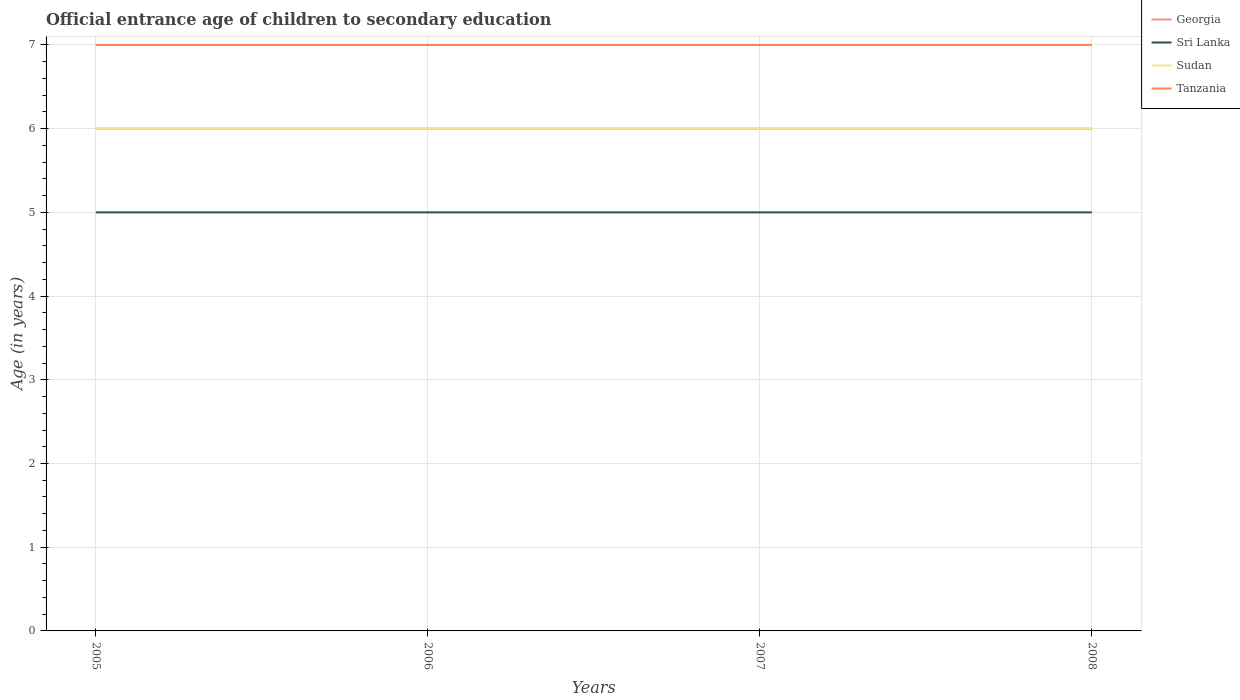In which year was the secondary school starting age of children in Georgia maximum?
Your response must be concise. 2005. What is the total secondary school starting age of children in Tanzania in the graph?
Keep it short and to the point. 0. What is the difference between the highest and the second highest secondary school starting age of children in Tanzania?
Make the answer very short. 0. What is the difference between the highest and the lowest secondary school starting age of children in Tanzania?
Offer a terse response. 0. Is the secondary school starting age of children in Sri Lanka strictly greater than the secondary school starting age of children in Sudan over the years?
Offer a terse response. Yes. How many years are there in the graph?
Offer a terse response. 4. How many legend labels are there?
Provide a succinct answer. 4. What is the title of the graph?
Make the answer very short. Official entrance age of children to secondary education. What is the label or title of the X-axis?
Offer a terse response. Years. What is the label or title of the Y-axis?
Make the answer very short. Age (in years). What is the Age (in years) of Sudan in 2005?
Your response must be concise. 6. What is the Age (in years) in Sri Lanka in 2006?
Your answer should be compact. 5. What is the Age (in years) of Sudan in 2006?
Offer a terse response. 6. What is the Age (in years) of Sri Lanka in 2007?
Make the answer very short. 5. What is the Age (in years) in Georgia in 2008?
Ensure brevity in your answer.  6. What is the Age (in years) in Sri Lanka in 2008?
Make the answer very short. 5. What is the Age (in years) of Sudan in 2008?
Your answer should be very brief. 6. What is the Age (in years) of Tanzania in 2008?
Ensure brevity in your answer.  7. Across all years, what is the maximum Age (in years) of Georgia?
Provide a succinct answer. 6. Across all years, what is the maximum Age (in years) in Sri Lanka?
Your response must be concise. 5. Across all years, what is the maximum Age (in years) of Sudan?
Your response must be concise. 6. Across all years, what is the minimum Age (in years) of Georgia?
Offer a terse response. 6. Across all years, what is the minimum Age (in years) in Sri Lanka?
Ensure brevity in your answer.  5. Across all years, what is the minimum Age (in years) of Sudan?
Your response must be concise. 6. What is the total Age (in years) of Sri Lanka in the graph?
Ensure brevity in your answer.  20. What is the difference between the Age (in years) in Georgia in 2005 and that in 2006?
Your answer should be very brief. 0. What is the difference between the Age (in years) in Georgia in 2005 and that in 2007?
Make the answer very short. 0. What is the difference between the Age (in years) of Sri Lanka in 2005 and that in 2007?
Your answer should be very brief. 0. What is the difference between the Age (in years) of Sudan in 2005 and that in 2007?
Your response must be concise. 0. What is the difference between the Age (in years) of Tanzania in 2005 and that in 2007?
Provide a short and direct response. 0. What is the difference between the Age (in years) of Georgia in 2005 and that in 2008?
Provide a succinct answer. 0. What is the difference between the Age (in years) in Sudan in 2005 and that in 2008?
Offer a terse response. 0. What is the difference between the Age (in years) in Tanzania in 2005 and that in 2008?
Your answer should be very brief. 0. What is the difference between the Age (in years) in Sri Lanka in 2006 and that in 2007?
Keep it short and to the point. 0. What is the difference between the Age (in years) in Tanzania in 2006 and that in 2007?
Your answer should be very brief. 0. What is the difference between the Age (in years) in Georgia in 2006 and that in 2008?
Your answer should be very brief. 0. What is the difference between the Age (in years) of Sri Lanka in 2006 and that in 2008?
Give a very brief answer. 0. What is the difference between the Age (in years) in Tanzania in 2006 and that in 2008?
Offer a terse response. 0. What is the difference between the Age (in years) of Tanzania in 2007 and that in 2008?
Your answer should be compact. 0. What is the difference between the Age (in years) of Georgia in 2005 and the Age (in years) of Sudan in 2006?
Your response must be concise. 0. What is the difference between the Age (in years) of Georgia in 2005 and the Age (in years) of Tanzania in 2006?
Offer a terse response. -1. What is the difference between the Age (in years) in Georgia in 2005 and the Age (in years) in Sri Lanka in 2007?
Provide a succinct answer. 1. What is the difference between the Age (in years) of Georgia in 2005 and the Age (in years) of Sudan in 2007?
Keep it short and to the point. 0. What is the difference between the Age (in years) of Georgia in 2005 and the Age (in years) of Tanzania in 2007?
Provide a succinct answer. -1. What is the difference between the Age (in years) of Sri Lanka in 2005 and the Age (in years) of Sudan in 2007?
Provide a succinct answer. -1. What is the difference between the Age (in years) in Sudan in 2005 and the Age (in years) in Tanzania in 2007?
Give a very brief answer. -1. What is the difference between the Age (in years) in Georgia in 2005 and the Age (in years) in Tanzania in 2008?
Offer a very short reply. -1. What is the difference between the Age (in years) of Sudan in 2005 and the Age (in years) of Tanzania in 2008?
Offer a terse response. -1. What is the difference between the Age (in years) of Georgia in 2006 and the Age (in years) of Sri Lanka in 2007?
Your answer should be compact. 1. What is the difference between the Age (in years) of Georgia in 2006 and the Age (in years) of Sudan in 2007?
Your answer should be very brief. 0. What is the difference between the Age (in years) in Sri Lanka in 2006 and the Age (in years) in Tanzania in 2007?
Ensure brevity in your answer.  -2. What is the difference between the Age (in years) in Georgia in 2006 and the Age (in years) in Sri Lanka in 2008?
Provide a short and direct response. 1. What is the difference between the Age (in years) in Georgia in 2006 and the Age (in years) in Tanzania in 2008?
Keep it short and to the point. -1. What is the difference between the Age (in years) in Georgia in 2007 and the Age (in years) in Tanzania in 2008?
Provide a short and direct response. -1. What is the difference between the Age (in years) of Sri Lanka in 2007 and the Age (in years) of Tanzania in 2008?
Offer a very short reply. -2. What is the difference between the Age (in years) in Sudan in 2007 and the Age (in years) in Tanzania in 2008?
Provide a short and direct response. -1. What is the average Age (in years) of Georgia per year?
Keep it short and to the point. 6. What is the average Age (in years) in Sri Lanka per year?
Your answer should be very brief. 5. What is the average Age (in years) in Tanzania per year?
Your answer should be very brief. 7. In the year 2005, what is the difference between the Age (in years) in Georgia and Age (in years) in Sri Lanka?
Your answer should be very brief. 1. In the year 2005, what is the difference between the Age (in years) in Georgia and Age (in years) in Sudan?
Your answer should be very brief. 0. In the year 2005, what is the difference between the Age (in years) in Georgia and Age (in years) in Tanzania?
Offer a very short reply. -1. In the year 2006, what is the difference between the Age (in years) in Sri Lanka and Age (in years) in Sudan?
Provide a short and direct response. -1. In the year 2006, what is the difference between the Age (in years) of Sri Lanka and Age (in years) of Tanzania?
Give a very brief answer. -2. In the year 2007, what is the difference between the Age (in years) of Georgia and Age (in years) of Sri Lanka?
Provide a short and direct response. 1. In the year 2007, what is the difference between the Age (in years) of Georgia and Age (in years) of Sudan?
Offer a terse response. 0. In the year 2007, what is the difference between the Age (in years) in Georgia and Age (in years) in Tanzania?
Provide a short and direct response. -1. In the year 2007, what is the difference between the Age (in years) in Sri Lanka and Age (in years) in Tanzania?
Offer a very short reply. -2. In the year 2008, what is the difference between the Age (in years) in Georgia and Age (in years) in Sudan?
Give a very brief answer. 0. In the year 2008, what is the difference between the Age (in years) in Sri Lanka and Age (in years) in Sudan?
Give a very brief answer. -1. What is the ratio of the Age (in years) in Georgia in 2005 to that in 2006?
Your answer should be very brief. 1. What is the ratio of the Age (in years) of Tanzania in 2005 to that in 2006?
Offer a very short reply. 1. What is the ratio of the Age (in years) in Georgia in 2005 to that in 2007?
Keep it short and to the point. 1. What is the ratio of the Age (in years) of Sri Lanka in 2005 to that in 2007?
Your answer should be very brief. 1. What is the ratio of the Age (in years) in Sudan in 2005 to that in 2007?
Ensure brevity in your answer.  1. What is the ratio of the Age (in years) in Tanzania in 2005 to that in 2007?
Provide a succinct answer. 1. What is the ratio of the Age (in years) in Sri Lanka in 2005 to that in 2008?
Make the answer very short. 1. What is the ratio of the Age (in years) in Sudan in 2005 to that in 2008?
Your answer should be compact. 1. What is the ratio of the Age (in years) in Sri Lanka in 2006 to that in 2007?
Your answer should be compact. 1. What is the ratio of the Age (in years) of Sudan in 2006 to that in 2007?
Ensure brevity in your answer.  1. What is the ratio of the Age (in years) of Tanzania in 2006 to that in 2007?
Provide a succinct answer. 1. What is the ratio of the Age (in years) in Georgia in 2006 to that in 2008?
Give a very brief answer. 1. What is the ratio of the Age (in years) in Tanzania in 2006 to that in 2008?
Offer a very short reply. 1. What is the ratio of the Age (in years) of Sri Lanka in 2007 to that in 2008?
Your answer should be very brief. 1. What is the ratio of the Age (in years) in Sudan in 2007 to that in 2008?
Provide a succinct answer. 1. What is the difference between the highest and the second highest Age (in years) in Sri Lanka?
Keep it short and to the point. 0. What is the difference between the highest and the second highest Age (in years) in Sudan?
Your response must be concise. 0. What is the difference between the highest and the second highest Age (in years) of Tanzania?
Give a very brief answer. 0. What is the difference between the highest and the lowest Age (in years) of Georgia?
Your answer should be compact. 0. What is the difference between the highest and the lowest Age (in years) in Sudan?
Keep it short and to the point. 0. 